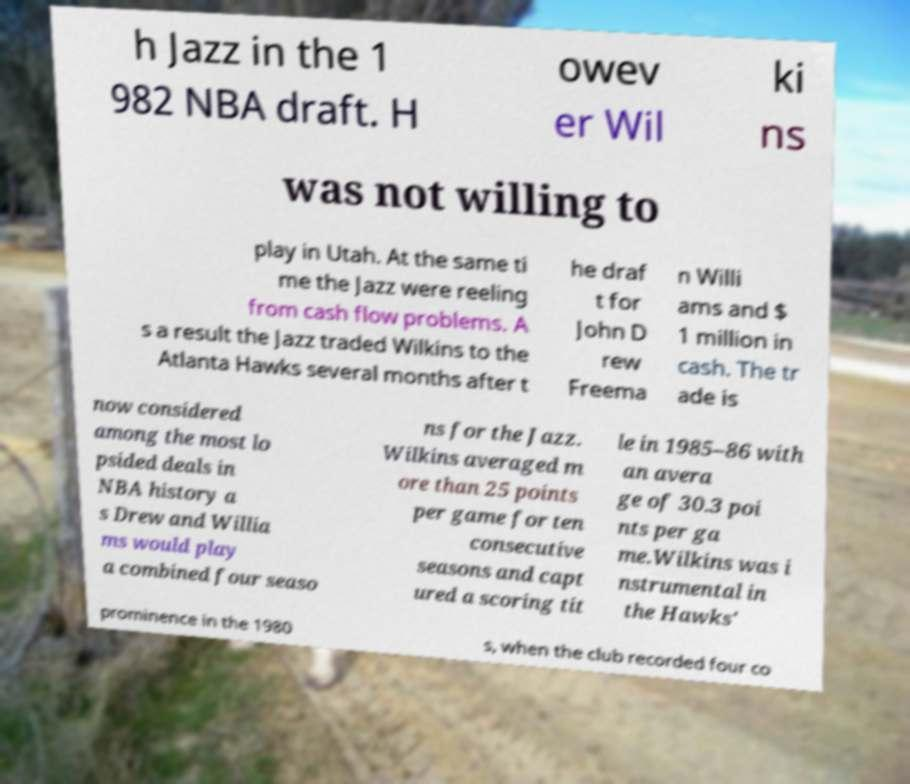Could you extract and type out the text from this image? h Jazz in the 1 982 NBA draft. H owev er Wil ki ns was not willing to play in Utah. At the same ti me the Jazz were reeling from cash flow problems. A s a result the Jazz traded Wilkins to the Atlanta Hawks several months after t he draf t for John D rew Freema n Willi ams and $ 1 million in cash. The tr ade is now considered among the most lo psided deals in NBA history a s Drew and Willia ms would play a combined four seaso ns for the Jazz. Wilkins averaged m ore than 25 points per game for ten consecutive seasons and capt ured a scoring tit le in 1985–86 with an avera ge of 30.3 poi nts per ga me.Wilkins was i nstrumental in the Hawks' prominence in the 1980 s, when the club recorded four co 